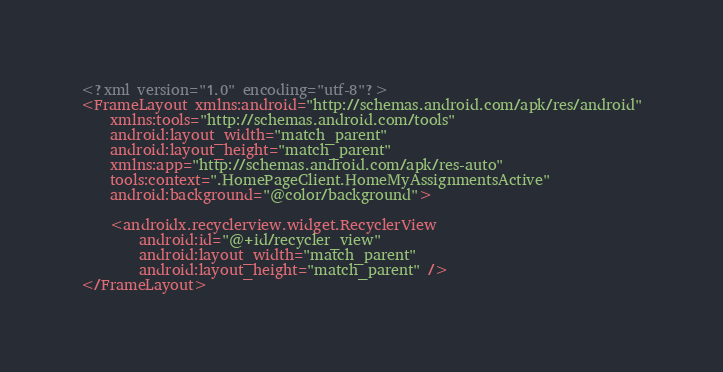Convert code to text. <code><loc_0><loc_0><loc_500><loc_500><_XML_><?xml version="1.0" encoding="utf-8"?>
<FrameLayout xmlns:android="http://schemas.android.com/apk/res/android"
    xmlns:tools="http://schemas.android.com/tools"
    android:layout_width="match_parent"
    android:layout_height="match_parent"
    xmlns:app="http://schemas.android.com/apk/res-auto"
    tools:context=".HomePageClient.HomeMyAssignmentsActive"
    android:background="@color/background">

    <androidx.recyclerview.widget.RecyclerView
        android:id="@+id/recycler_view"
        android:layout_width="match_parent"
        android:layout_height="match_parent" />
</FrameLayout></code> 